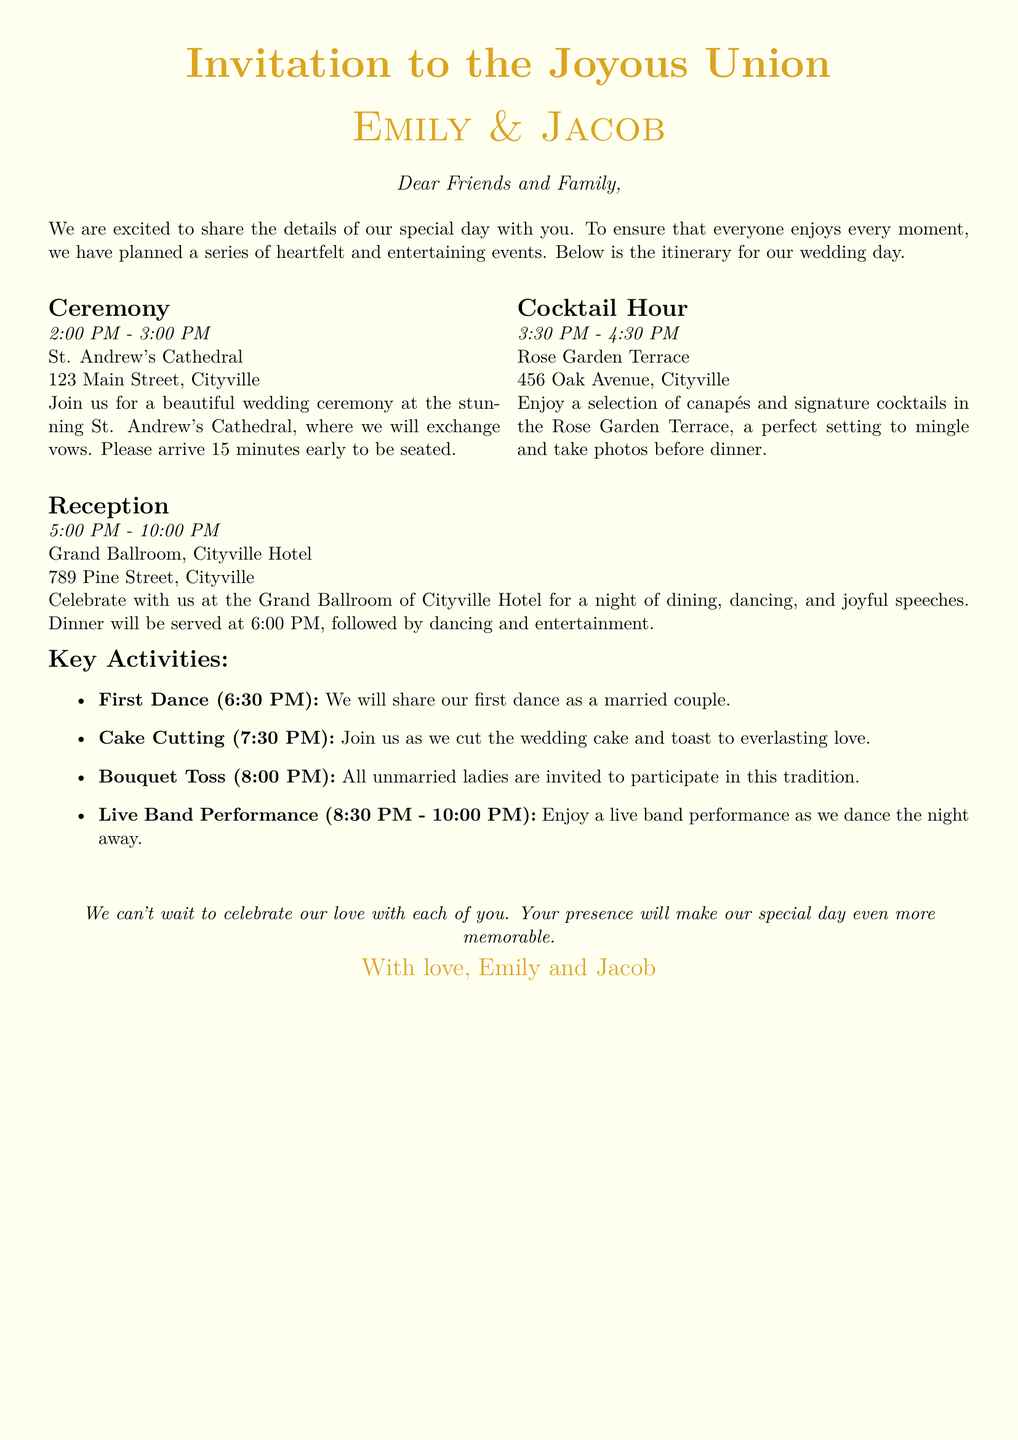what time does the ceremony start? The ceremony begins at 2:00 PM, as indicated in the itinerary.
Answer: 2:00 PM where will the cocktail hour take place? The cocktail hour is scheduled to be at the Rose Garden Terrace, which is specified in the document.
Answer: Rose Garden Terrace what is the address of the reception venue? The address of the reception venue, Grand Ballroom, is listed in the itinerary as 789 Pine Street, Cityville.
Answer: 789 Pine Street, Cityville what activity occurs at 6:30 PM? The first dance takes place at 6:30 PM, as detailed in the key activities section.
Answer: First Dance how long will the reception last? The reception is scheduled from 5:00 PM to 10:00 PM, so it lasts for 5 hours.
Answer: 5 hours what is the first key activity listed? The first key activity mentioned is the First Dance, as outlined in the document.
Answer: First Dance how many total activities are listed in the key activities section? There are four activities listed in the key activities section of the invitation.
Answer: Four who are the invitees addressed in the document? The invitees are referred to as "Dear Friends and Family," as stated at the beginning of the invitation.
Answer: Friends and Family what time should guests arrive for the ceremony? Guests are requested to arrive 15 minutes early to be seated for the ceremony.
Answer: 15 minutes early 